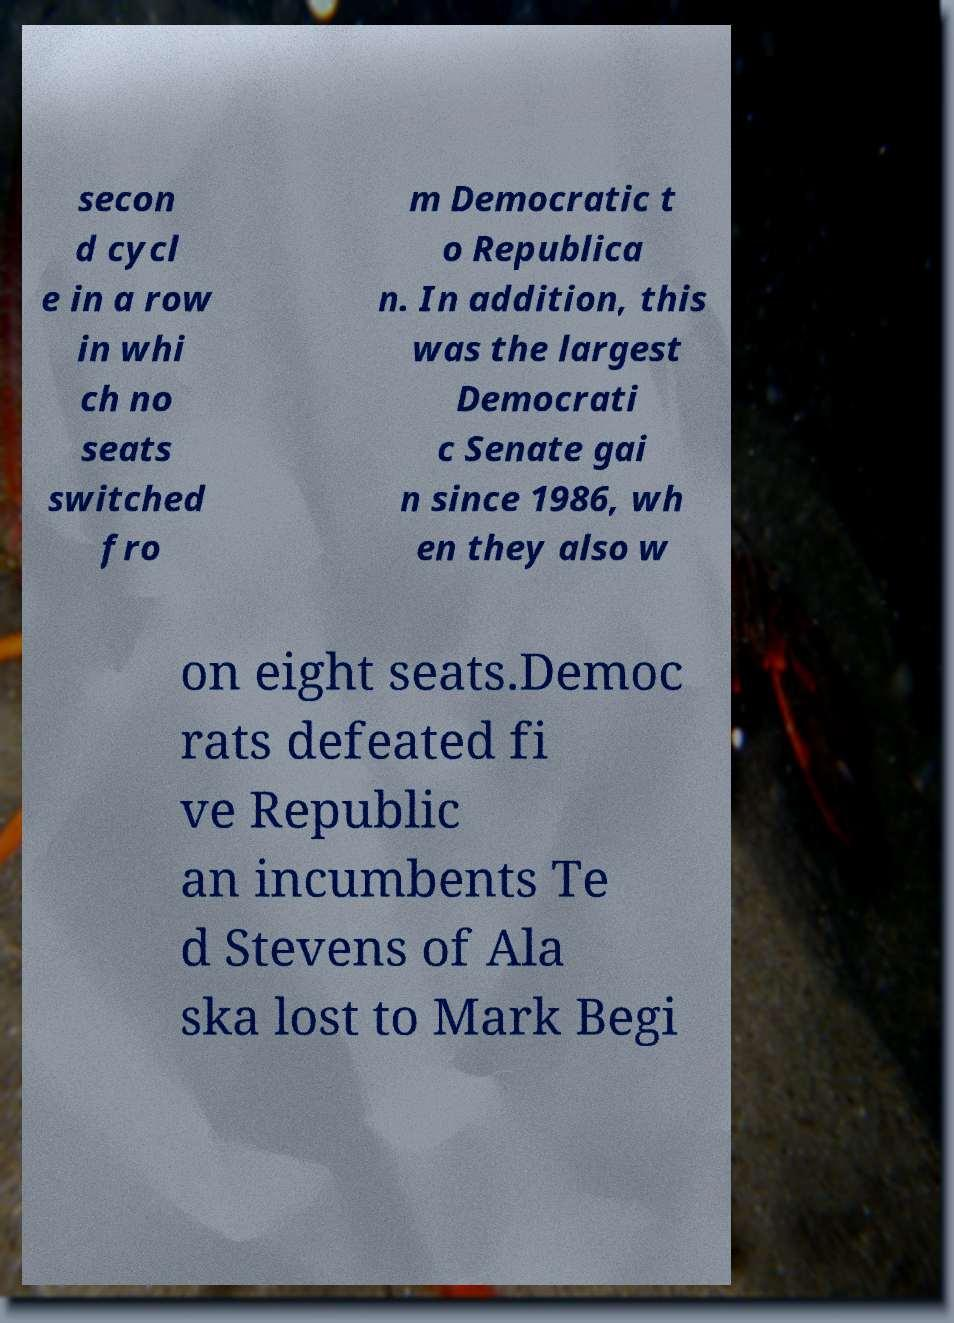For documentation purposes, I need the text within this image transcribed. Could you provide that? secon d cycl e in a row in whi ch no seats switched fro m Democratic t o Republica n. In addition, this was the largest Democrati c Senate gai n since 1986, wh en they also w on eight seats.Democ rats defeated fi ve Republic an incumbents Te d Stevens of Ala ska lost to Mark Begi 